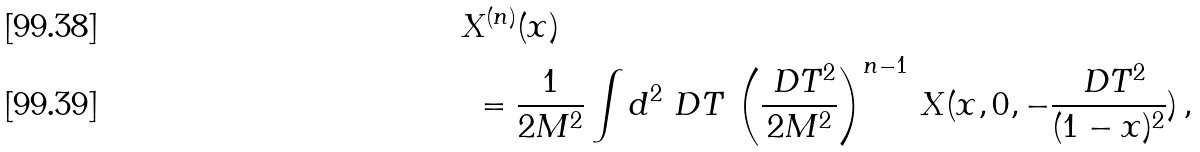<formula> <loc_0><loc_0><loc_500><loc_500>& X ^ { ( n ) } ( x ) \\ & \ = \frac { 1 } { 2 M ^ { 2 } } \int d ^ { 2 } \ D T \, \left ( \frac { \ D T ^ { 2 } } { 2 M ^ { 2 } } \right ) ^ { n - 1 } \, X ( x , 0 , - \frac { \ D T ^ { 2 } } { ( 1 - x ) ^ { 2 } } ) \, ,</formula> 